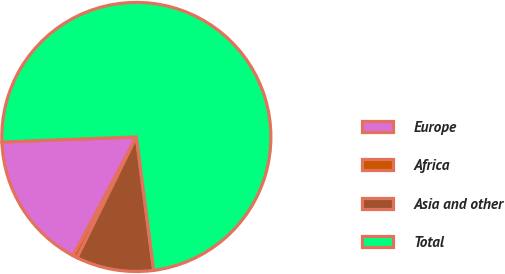<chart> <loc_0><loc_0><loc_500><loc_500><pie_chart><fcel>Europe<fcel>Africa<fcel>Asia and other<fcel>Total<nl><fcel>16.62%<fcel>0.52%<fcel>9.32%<fcel>73.54%<nl></chart> 